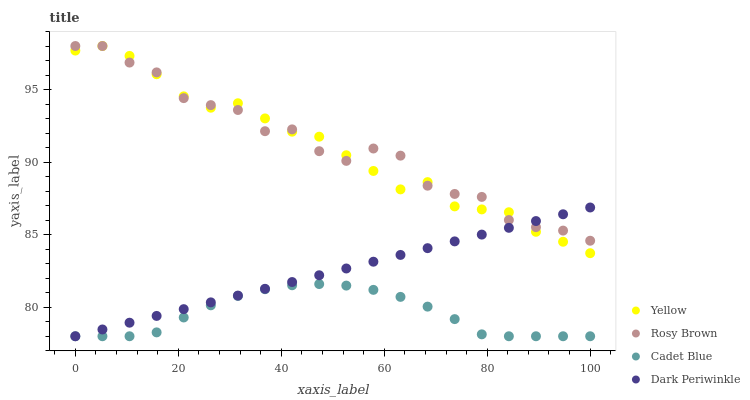Does Cadet Blue have the minimum area under the curve?
Answer yes or no. Yes. Does Rosy Brown have the maximum area under the curve?
Answer yes or no. Yes. Does Dark Periwinkle have the minimum area under the curve?
Answer yes or no. No. Does Dark Periwinkle have the maximum area under the curve?
Answer yes or no. No. Is Dark Periwinkle the smoothest?
Answer yes or no. Yes. Is Rosy Brown the roughest?
Answer yes or no. Yes. Is Rosy Brown the smoothest?
Answer yes or no. No. Is Dark Periwinkle the roughest?
Answer yes or no. No. Does Cadet Blue have the lowest value?
Answer yes or no. Yes. Does Rosy Brown have the lowest value?
Answer yes or no. No. Does Yellow have the highest value?
Answer yes or no. Yes. Does Dark Periwinkle have the highest value?
Answer yes or no. No. Is Cadet Blue less than Rosy Brown?
Answer yes or no. Yes. Is Yellow greater than Cadet Blue?
Answer yes or no. Yes. Does Rosy Brown intersect Yellow?
Answer yes or no. Yes. Is Rosy Brown less than Yellow?
Answer yes or no. No. Is Rosy Brown greater than Yellow?
Answer yes or no. No. Does Cadet Blue intersect Rosy Brown?
Answer yes or no. No. 